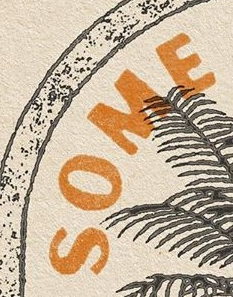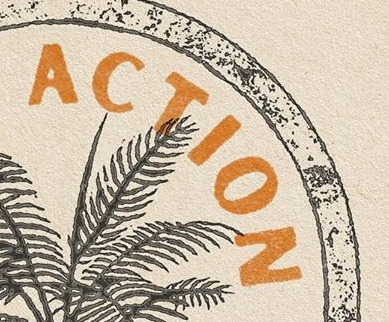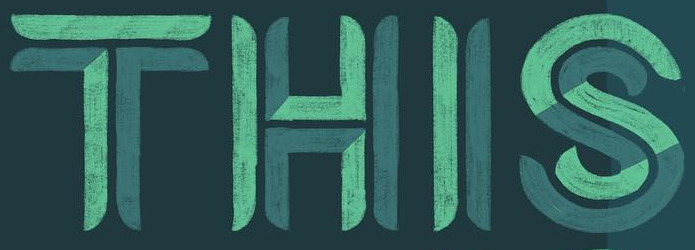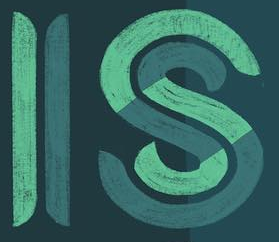What words can you see in these images in sequence, separated by a semicolon? SOME; ACTION; THIS; IS 